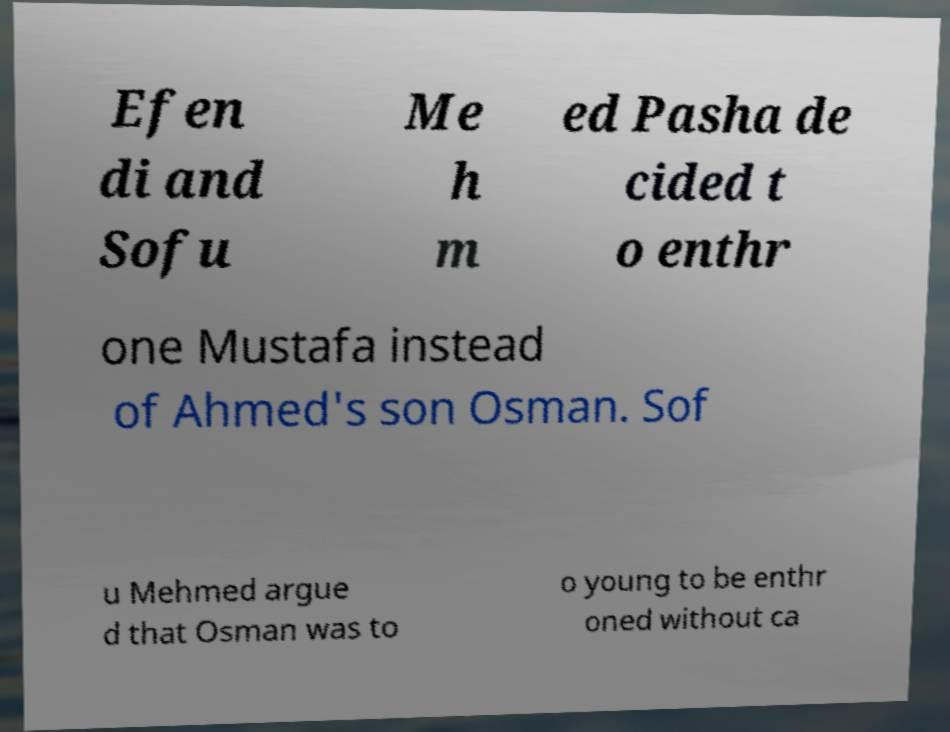Please identify and transcribe the text found in this image. Efen di and Sofu Me h m ed Pasha de cided t o enthr one Mustafa instead of Ahmed's son Osman. Sof u Mehmed argue d that Osman was to o young to be enthr oned without ca 